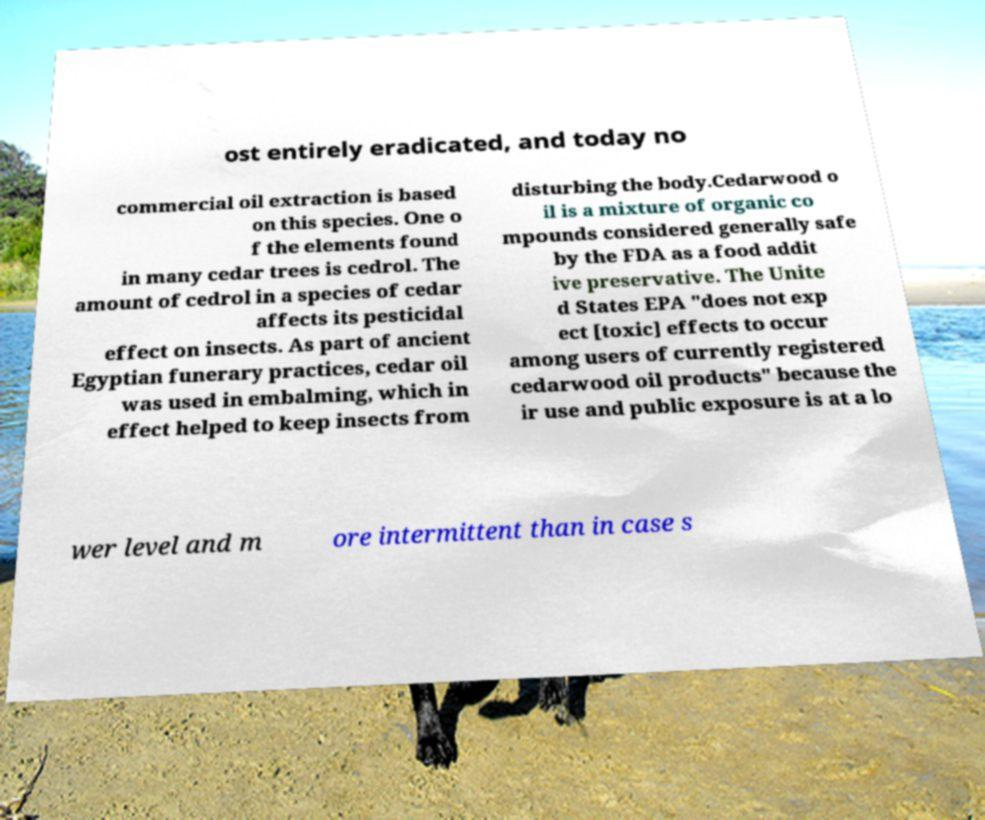Please identify and transcribe the text found in this image. ost entirely eradicated, and today no commercial oil extraction is based on this species. One o f the elements found in many cedar trees is cedrol. The amount of cedrol in a species of cedar affects its pesticidal effect on insects. As part of ancient Egyptian funerary practices, cedar oil was used in embalming, which in effect helped to keep insects from disturbing the body.Cedarwood o il is a mixture of organic co mpounds considered generally safe by the FDA as a food addit ive preservative. The Unite d States EPA "does not exp ect [toxic] effects to occur among users of currently registered cedarwood oil products" because the ir use and public exposure is at a lo wer level and m ore intermittent than in case s 